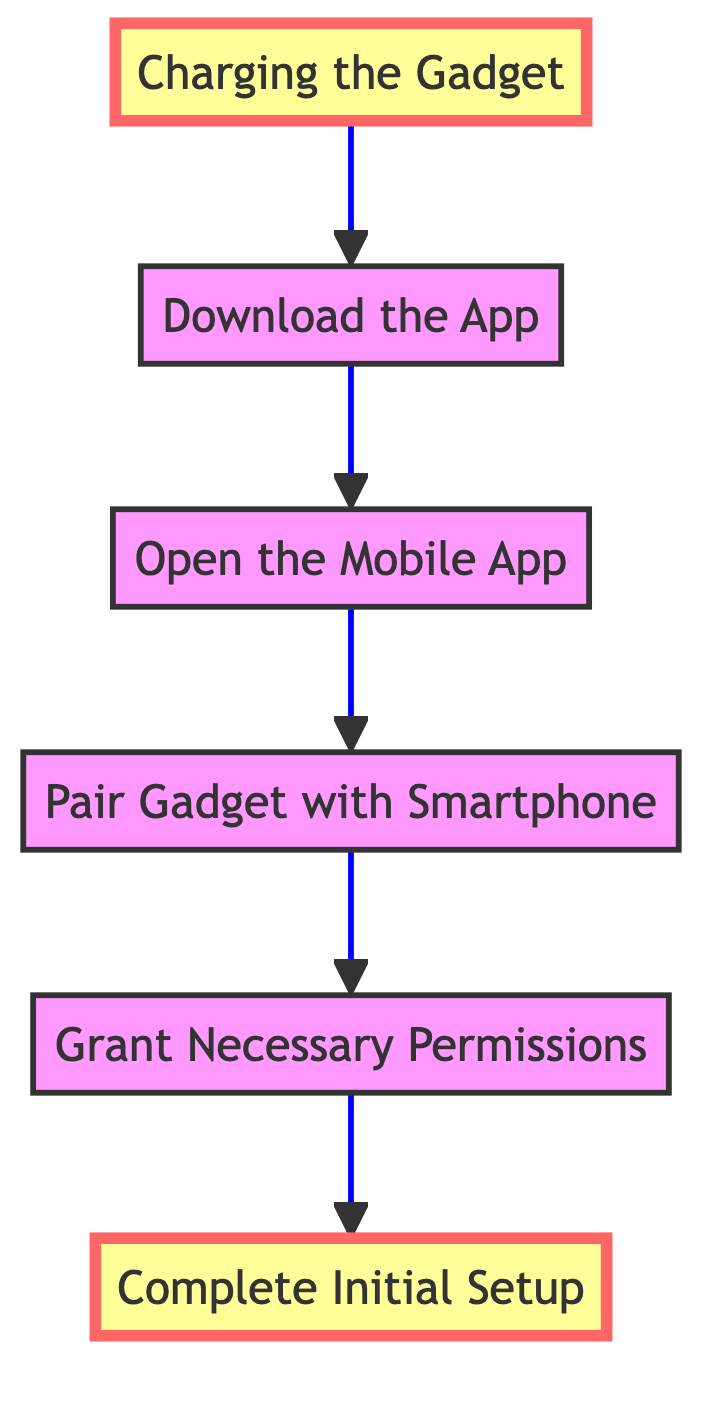What is the first step shown in the diagram? The diagram indicates that the first step, at the top of the flow, is "Complete Initial Setup," as it is the final action to be completed after following all the previous steps.
Answer: Complete Initial Setup How many total steps are there in the diagram? The diagram displays a total of six steps that lead from the bottom to the top of the flowchart.
Answer: 6 What step comes after "Open the Mobile App"? The step that comes after "Open the Mobile App" in the flowchart is "Pair Gadget with Smartphone," indicating the next action to take after launching the app.
Answer: Pair Gadget with Smartphone What is the relationship between "Charging the Gadget" and "Download the App"? The relationship indicates that "Charging the Gadget" must be completed before proceeding to "Download the App," showing the progression in the process required for connecting the device.
Answer: Charging the Gadget → Download the App Which step requires granting permissions? The step that requires granting permissions is "Grant Necessary Permissions," as indicated in the diagram prior to the pairing step, necessitating permission for the gadget to function properly.
Answer: Grant Necessary Permissions What action occurs before "Complete Initial Setup"? Before "Complete Initial Setup" can be achieved, all previous steps must be taken, specifically the step "Grant Necessary Permissions," indicating that all prerequisites must be fulfilled.
Answer: Grant Necessary Permissions What do you need to do after "Download the App"? After "Download the App," the next action indicated in the diagram is to "Open the Mobile App," which is essential before making any further connections or configurations.
Answer: Open the Mobile App Which two actions are highlighted in the diagram? The highlighted actions in the diagram are "Charging the Gadget" and "Complete Initial Setup," emphasizing the importance of both steps in the overall process.
Answer: Charging the Gadget and Complete Initial Setup 